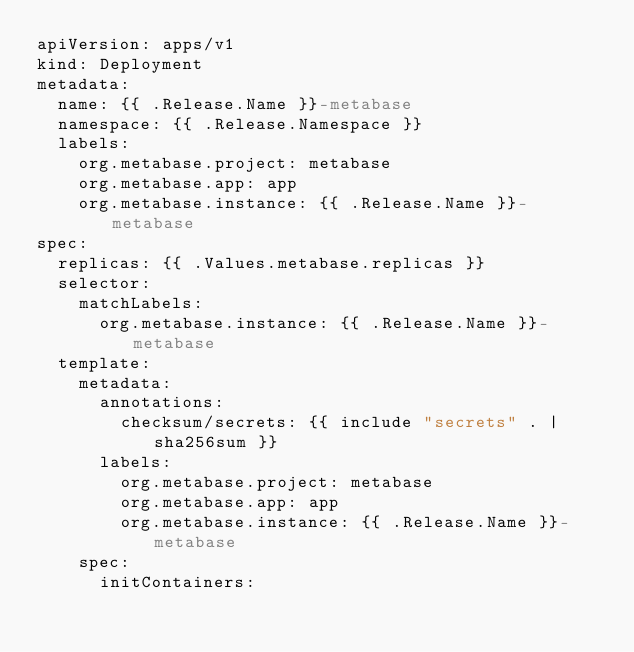<code> <loc_0><loc_0><loc_500><loc_500><_YAML_>apiVersion: apps/v1
kind: Deployment
metadata:
  name: {{ .Release.Name }}-metabase
  namespace: {{ .Release.Namespace }}
  labels:
    org.metabase.project: metabase
    org.metabase.app: app
    org.metabase.instance: {{ .Release.Name }}-metabase
spec:
  replicas: {{ .Values.metabase.replicas }}
  selector:
    matchLabels:
      org.metabase.instance: {{ .Release.Name }}-metabase
  template:
    metadata:
      annotations:
        checksum/secrets: {{ include "secrets" . | sha256sum }}
      labels:
        org.metabase.project: metabase
        org.metabase.app: app
        org.metabase.instance: {{ .Release.Name }}-metabase
    spec:
      initContainers:</code> 